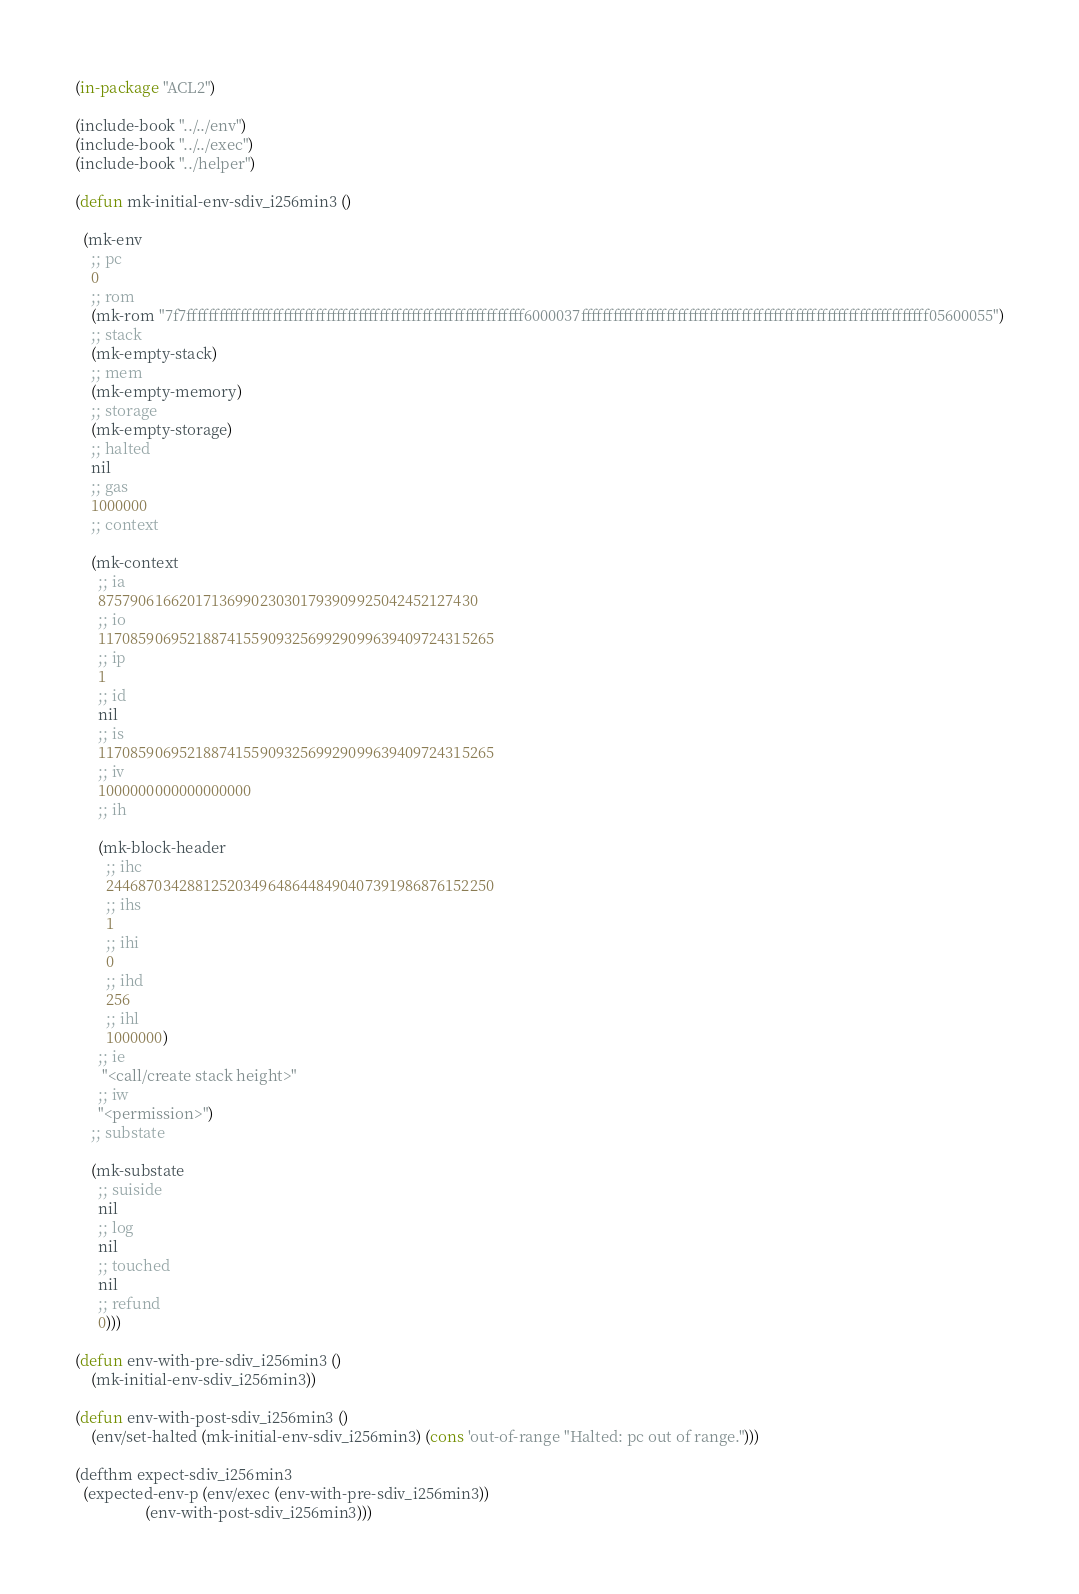<code> <loc_0><loc_0><loc_500><loc_500><_Lisp_>
(in-package "ACL2")

(include-book "../../env")
(include-book "../../exec")
(include-book "../helper")

(defun mk-initial-env-sdiv_i256min3 ()

  (mk-env
    ;; pc
    0
    ;; rom
    (mk-rom "7f7fffffffffffffffffffffffffffffffffffffffffffffffffffffffffffffff6000037fffffffffffffffffffffffffffffffffffffffffffffffffffffffffffffffff05600055")
    ;; stack
    (mk-empty-stack)
    ;; mem
    (mk-empty-memory)
    ;; storage
    (mk-empty-storage)
    ;; halted
    nil
    ;; gas
    1000000
    ;; context
  
    (mk-context
      ;; ia
      87579061662017136990230301793909925042452127430
      ;; io
      1170859069521887415590932569929099639409724315265
      ;; ip
      1
      ;; id
      nil
      ;; is
      1170859069521887415590932569929099639409724315265
      ;; iv
      1000000000000000000
      ;; ih
  
      (mk-block-header
        ;; ihc
        244687034288125203496486448490407391986876152250
        ;; ihs
        1
        ;; ihi
        0
        ;; ihd
        256
        ;; ihl
        1000000)
      ;; ie
       "<call/create stack height>"
      ;; iw
      "<permission>")
    ;; substate
  
    (mk-substate
      ;; suiside
      nil
      ;; log
      nil
      ;; touched
      nil
      ;; refund
      0)))

(defun env-with-pre-sdiv_i256min3 ()
    (mk-initial-env-sdiv_i256min3))

(defun env-with-post-sdiv_i256min3 ()
    (env/set-halted (mk-initial-env-sdiv_i256min3) (cons 'out-of-range "Halted: pc out of range.")))

(defthm expect-sdiv_i256min3
  (expected-env-p (env/exec (env-with-pre-sdiv_i256min3))
                  (env-with-post-sdiv_i256min3)))</code> 